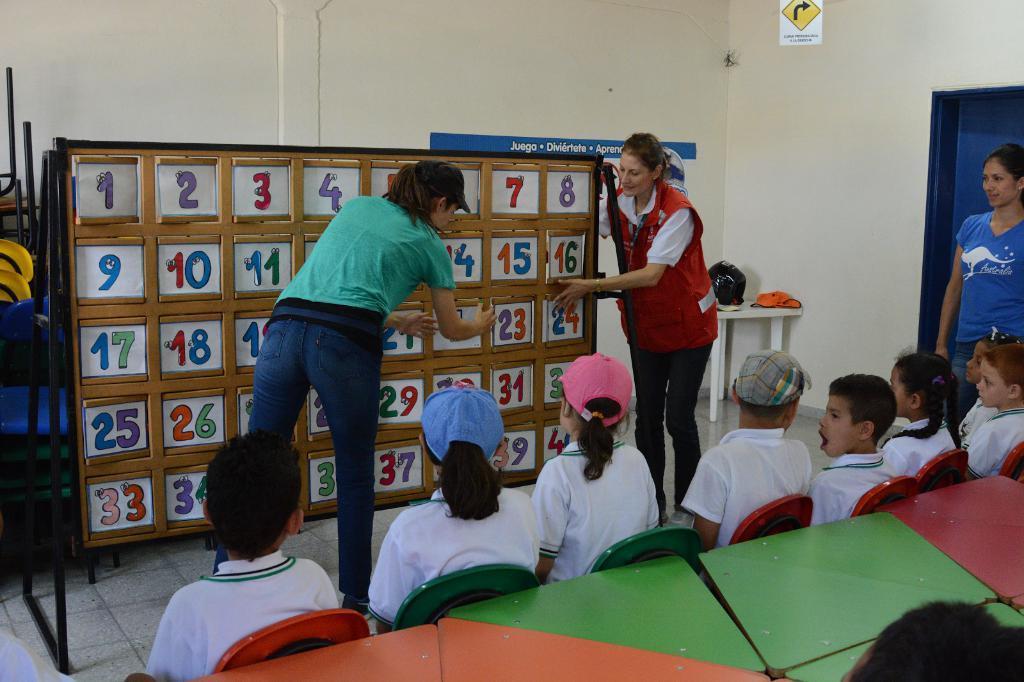Please provide a concise description of this image. In this picture there are children those who are sitting on the chairs at the bottom side of the image and there are girls in the center of the image, there is a numbers board in the center of the image. 